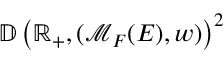<formula> <loc_0><loc_0><loc_500><loc_500>\mathbb { D } \left ( \mathbb { R } _ { + } , ( \mathcal { M } _ { F } ( E ) , w ) \right ) ^ { 2 }</formula> 